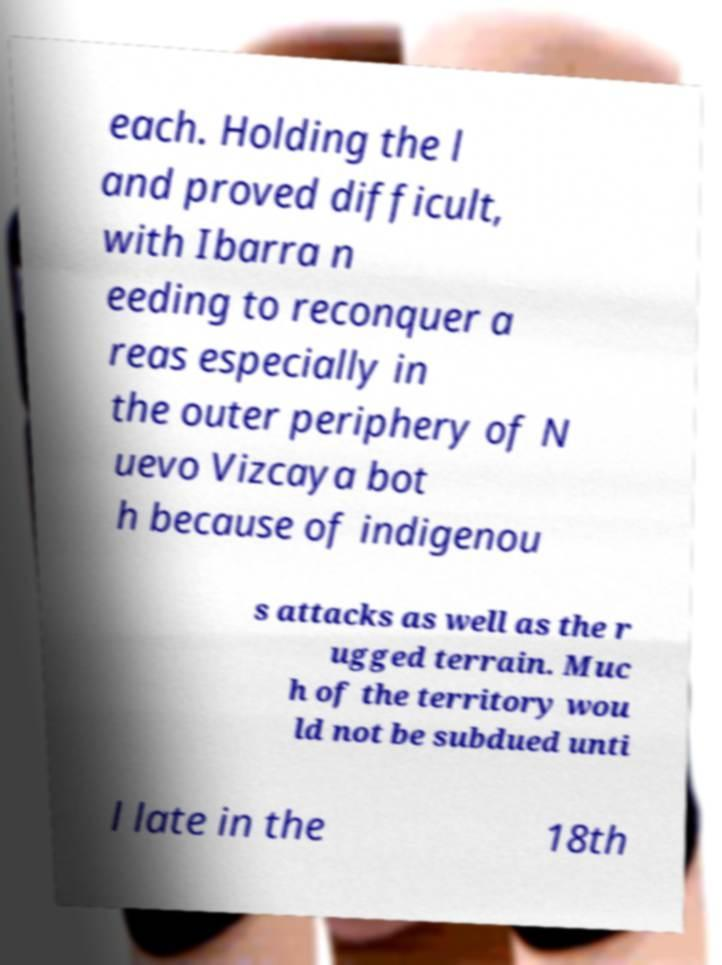For documentation purposes, I need the text within this image transcribed. Could you provide that? each. Holding the l and proved difficult, with Ibarra n eeding to reconquer a reas especially in the outer periphery of N uevo Vizcaya bot h because of indigenou s attacks as well as the r ugged terrain. Muc h of the territory wou ld not be subdued unti l late in the 18th 